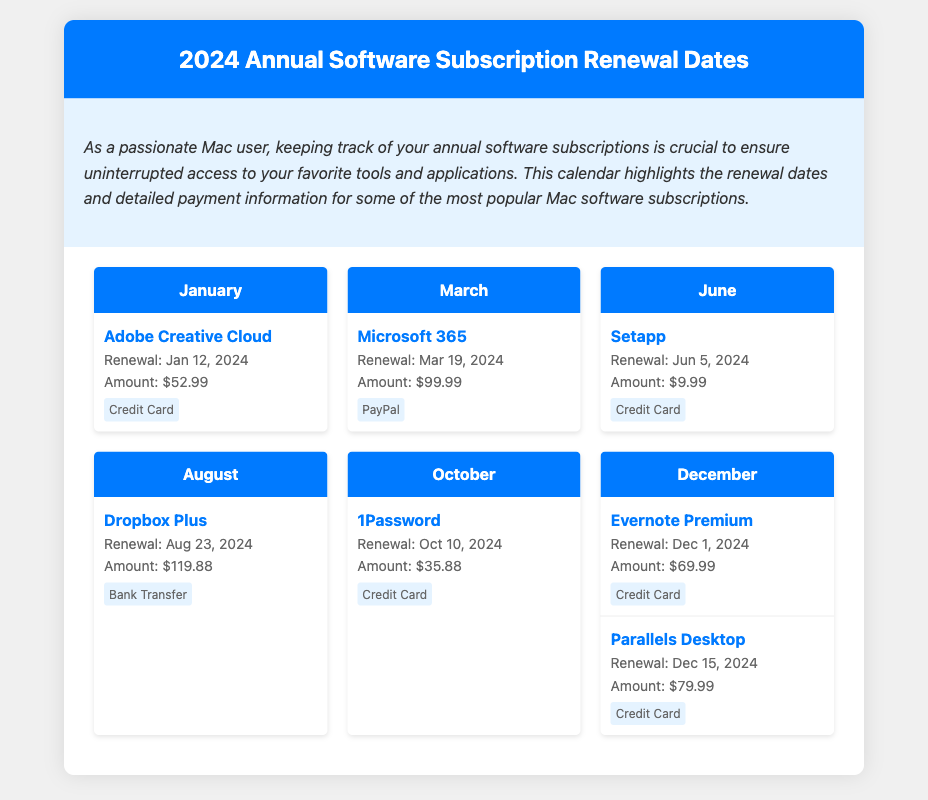What is the renewal date for Adobe Creative Cloud? The renewal date for Adobe Creative Cloud is specified in the January section of the document.
Answer: Jan 12, 2024 What payment method is used for Microsoft 365? The payment method for Microsoft 365 is outlined in the March section of the document.
Answer: PayPal How much is the renewal fee for Setapp? The renewal fee for Setapp is listed in the June section of the document.
Answer: $9.99 Which software subscription has the highest renewal amount? To determine the highest renewal amount, we can compare the amounts listed for all subscriptions in the document.
Answer: Dropbox Plus When is the renewal for Evernote Premium? The renewal date for Evernote Premium is provided in the December section of the document.
Answer: Dec 1, 2024 How many software subscriptions are listed for December? The number of software subscriptions listed for December can be counted from the relevant section.
Answer: 2 What month has the renewal date for 1Password? The month for 1Password's renewal is noted in the October section of the document.
Answer: October Which subscription renews on Mar 19, 2024? Mar 19, 2024, is specifically mentioned for one of the subscriptions in the March section.
Answer: Microsoft 365 